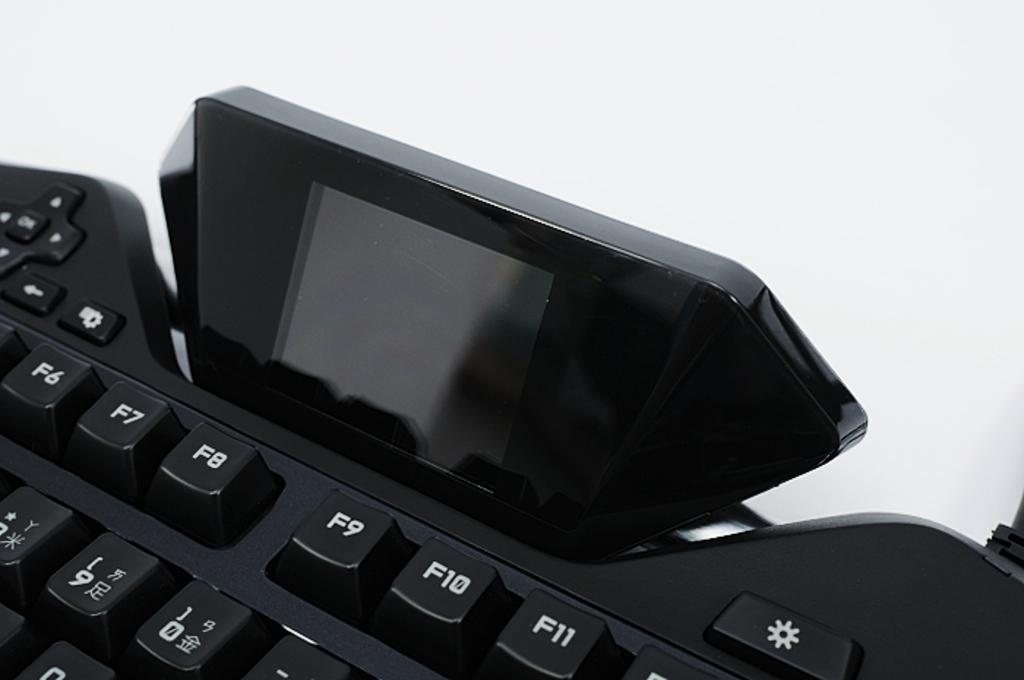<image>
Offer a succinct explanation of the picture presented. a keyboard with F10 at the top of it 